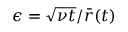<formula> <loc_0><loc_0><loc_500><loc_500>\epsilon = \sqrt { \nu t } / { \bar { r } } ( t )</formula> 